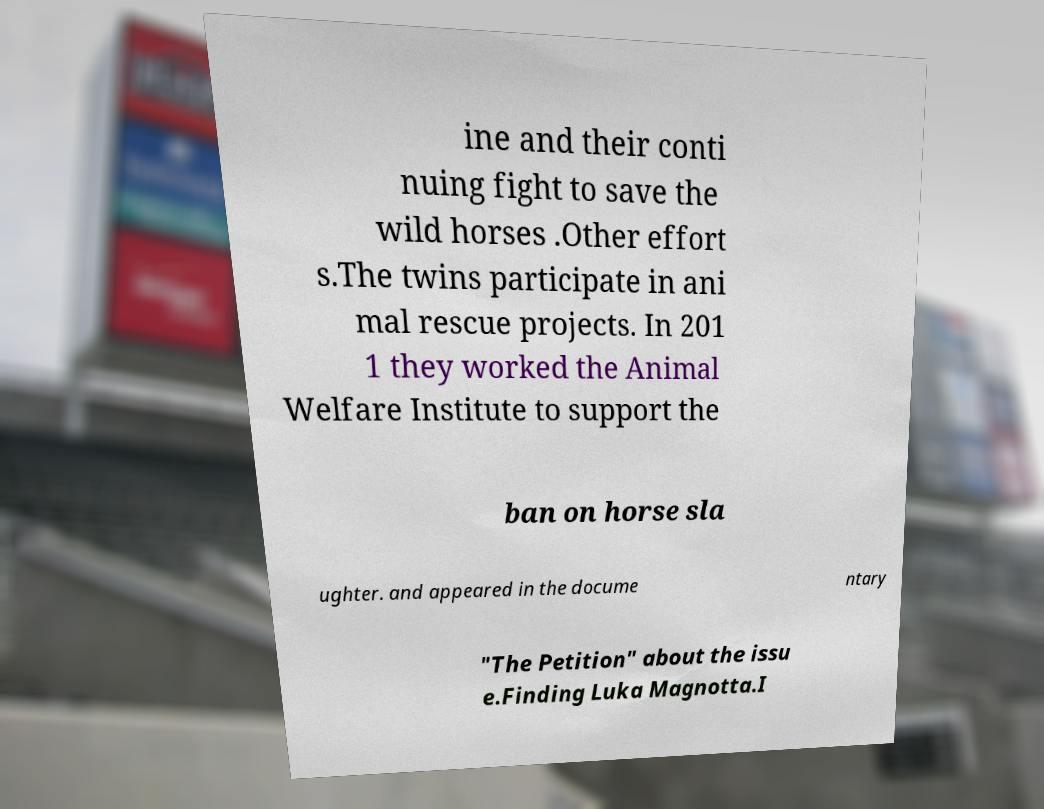For documentation purposes, I need the text within this image transcribed. Could you provide that? ine and their conti nuing fight to save the wild horses .Other effort s.The twins participate in ani mal rescue projects. In 201 1 they worked the Animal Welfare Institute to support the ban on horse sla ughter. and appeared in the docume ntary "The Petition" about the issu e.Finding Luka Magnotta.I 